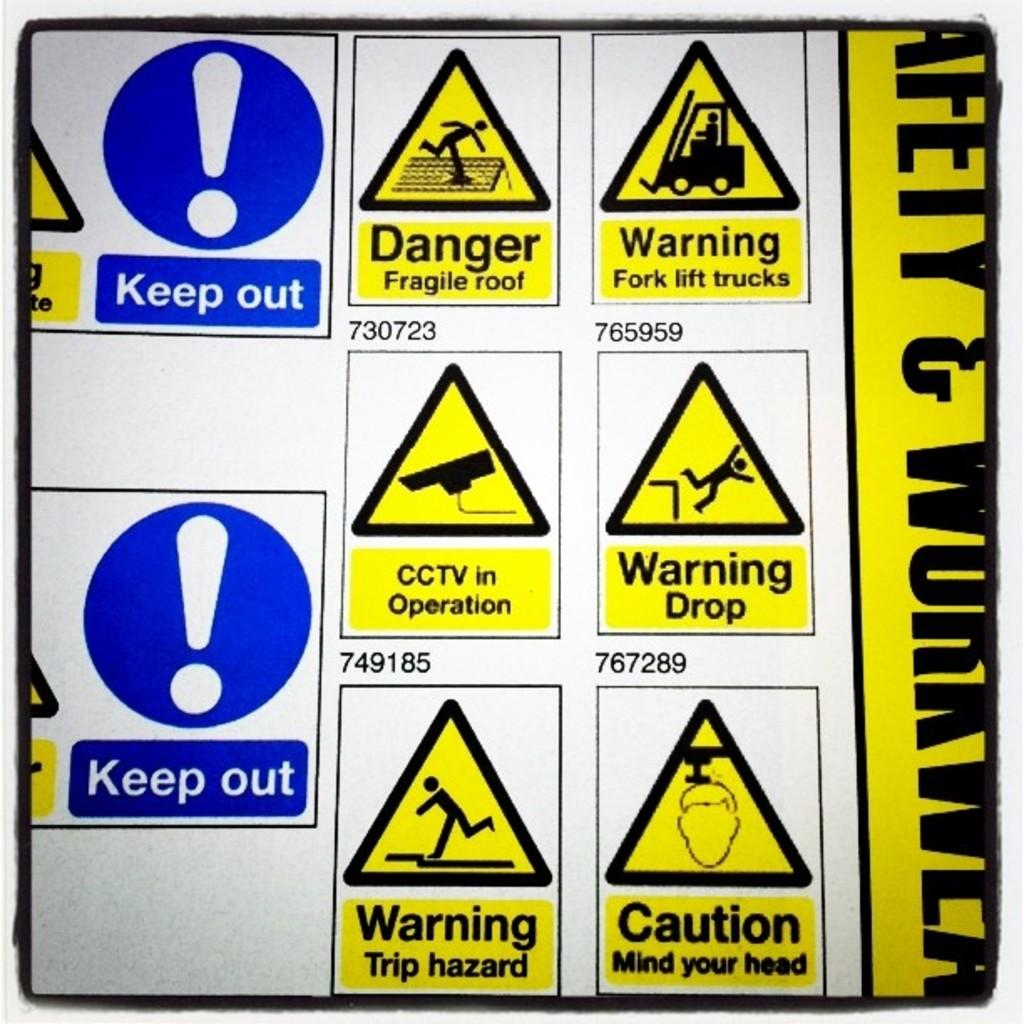Provide a one-sentence caption for the provided image. six yellow triangles with danger and warnings signs and two blu Keep out sign with cicrcle shape and exclamation  sign. 